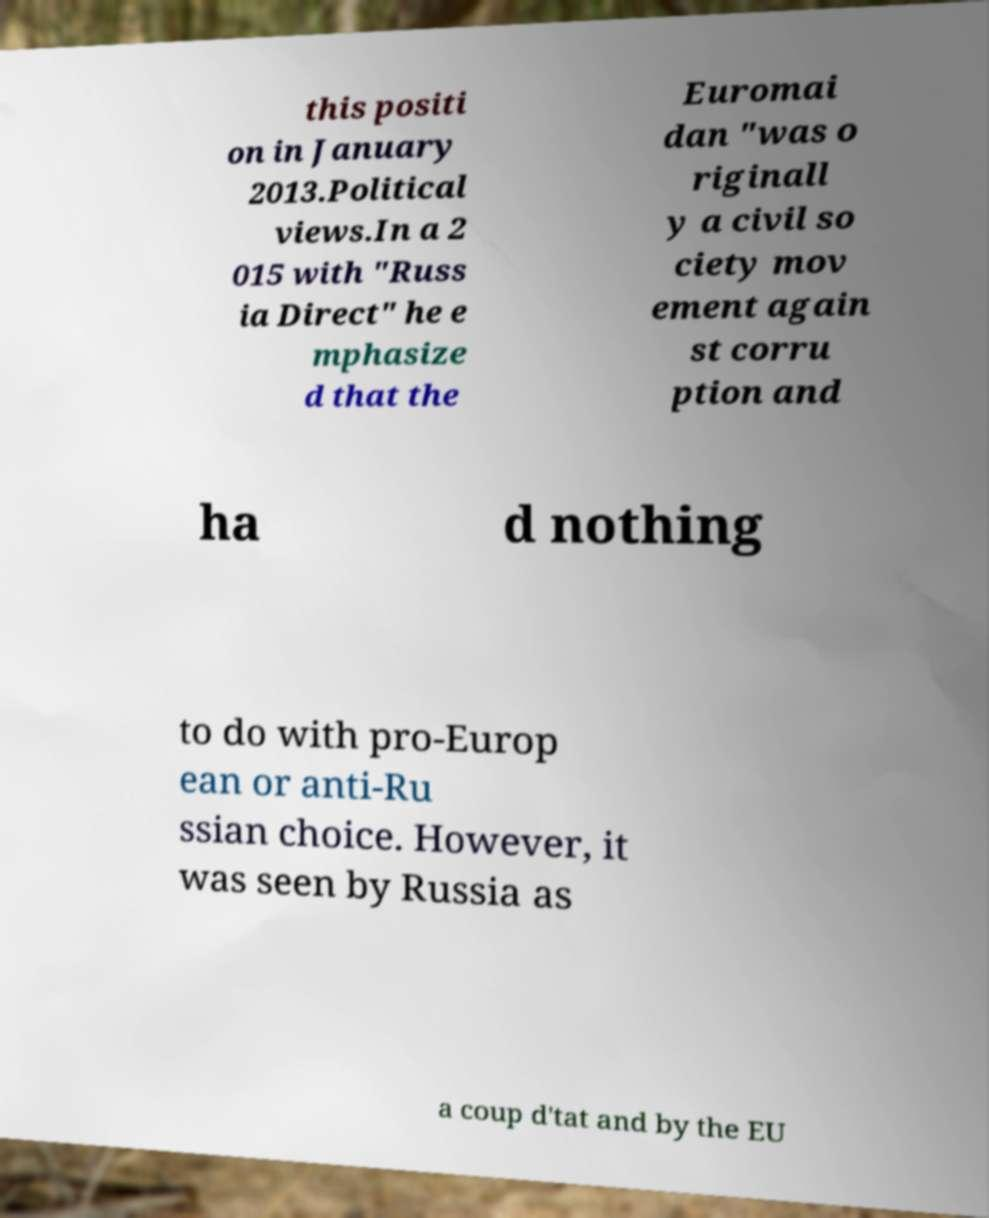What messages or text are displayed in this image? I need them in a readable, typed format. this positi on in January 2013.Political views.In a 2 015 with "Russ ia Direct" he e mphasize d that the Euromai dan "was o riginall y a civil so ciety mov ement again st corru ption and ha d nothing to do with pro-Europ ean or anti-Ru ssian choice. However, it was seen by Russia as a coup d'tat and by the EU 